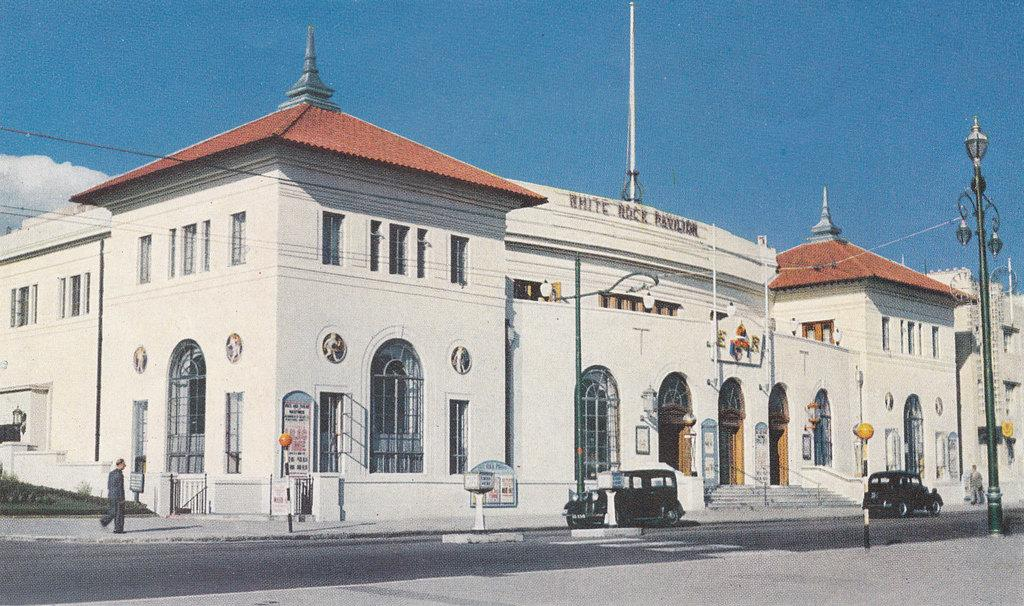What is happening on the left side of the image? There is a man walking on the left side of the image. What can be seen on the road in the image? Two vehicles are moving on the road in the image. What is the main structure in the middle of the image? There is a big building in the middle of the image. What is visible at the top of the image? The sky is visible at the top of the image. How many bushes are present in the image? There is no mention of bushes in the provided facts, so we cannot determine their presence or quantity in the image. Are there any geese flying in the sky in the image? There is no mention of geese in the provided facts, so we cannot determine their presence in the image. 